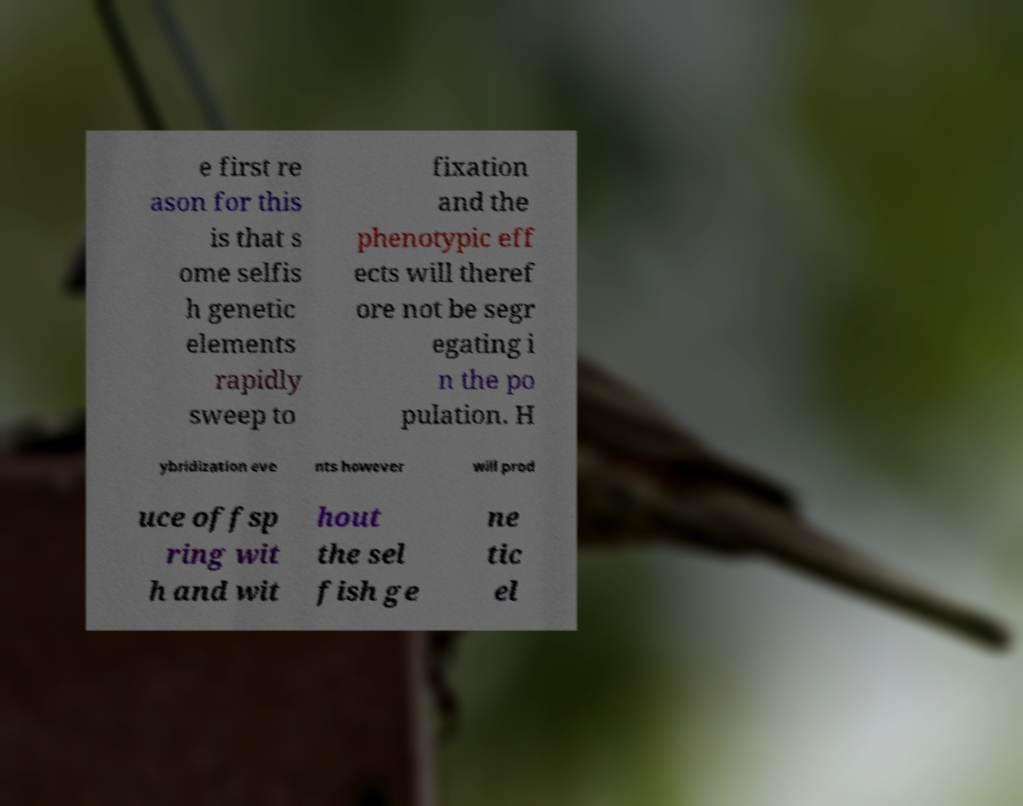Can you accurately transcribe the text from the provided image for me? e first re ason for this is that s ome selfis h genetic elements rapidly sweep to fixation and the phenotypic eff ects will theref ore not be segr egating i n the po pulation. H ybridization eve nts however will prod uce offsp ring wit h and wit hout the sel fish ge ne tic el 